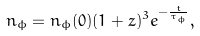<formula> <loc_0><loc_0><loc_500><loc_500>n _ { \phi } = n _ { \phi } ( 0 ) ( 1 + z ) ^ { 3 } e ^ { - \frac { t } { \tau _ { \phi } } } ,</formula> 